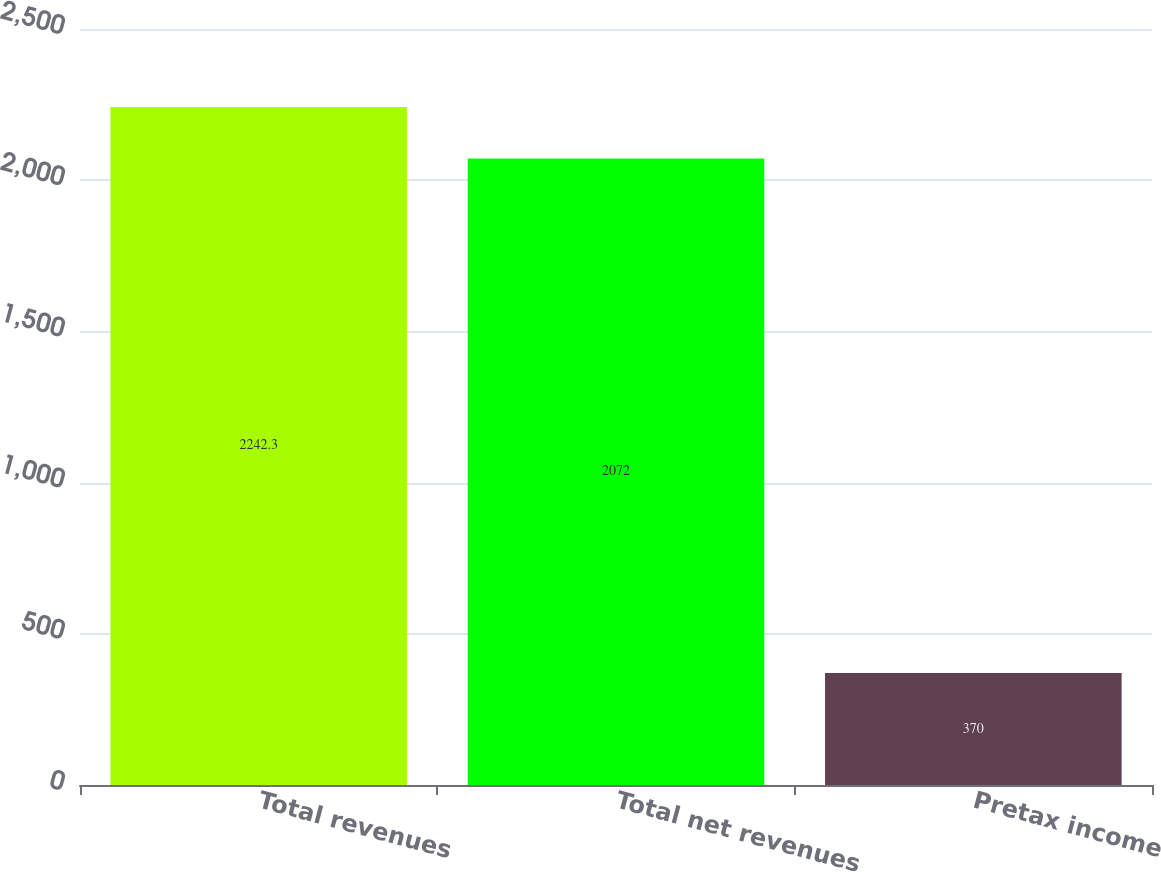<chart> <loc_0><loc_0><loc_500><loc_500><bar_chart><fcel>Total revenues<fcel>Total net revenues<fcel>Pretax income<nl><fcel>2242.3<fcel>2072<fcel>370<nl></chart> 